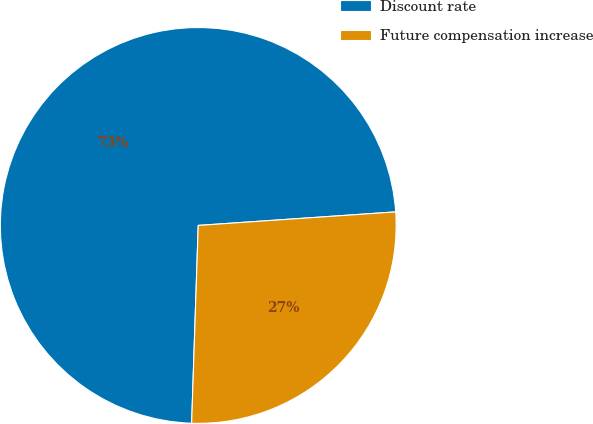Convert chart to OTSL. <chart><loc_0><loc_0><loc_500><loc_500><pie_chart><fcel>Discount rate<fcel>Future compensation increase<nl><fcel>73.38%<fcel>26.62%<nl></chart> 